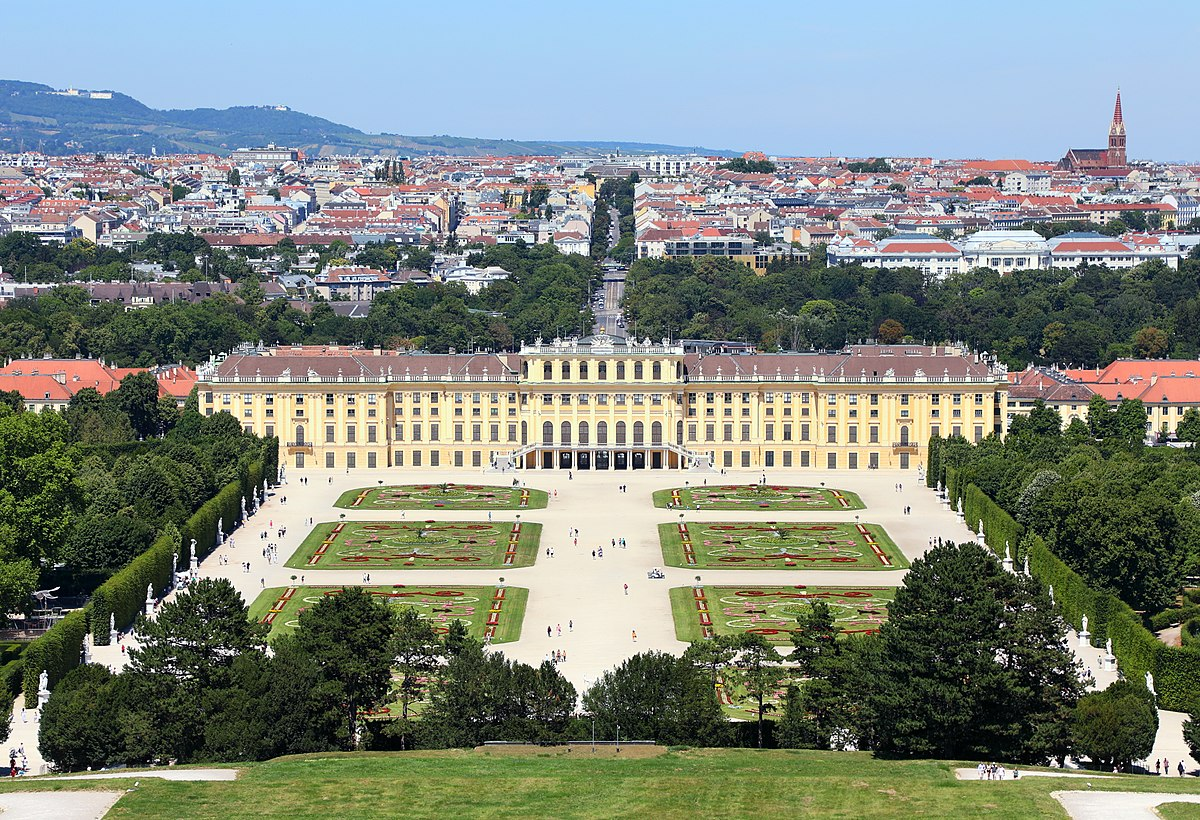What do you see happening in this image? The image offers a splendid view of the Schonbrunn Palace in Vienna, Austria, showcasing its classic Baroque architecture characterized by its distinctive yellow facade, white decorative details, and a striking green roof. Nestled amidst vast, beautifully arranged gardens that feature symmetrical patterns, ornate sculptures, and vibrant flowerbeds, the palace stands as a testament to royal aesthetics and precision in landscape design. In the distance, the urban sprawl of Vienna provides a contrasting backdrop, accentuating the palace's historical importance as a cultural and architectural landmark. This panoramic perspective not only captures the physical beauty of Schonbrunn but also invites appreciation for its role as a center of political events and artistic patronage throughout history. 